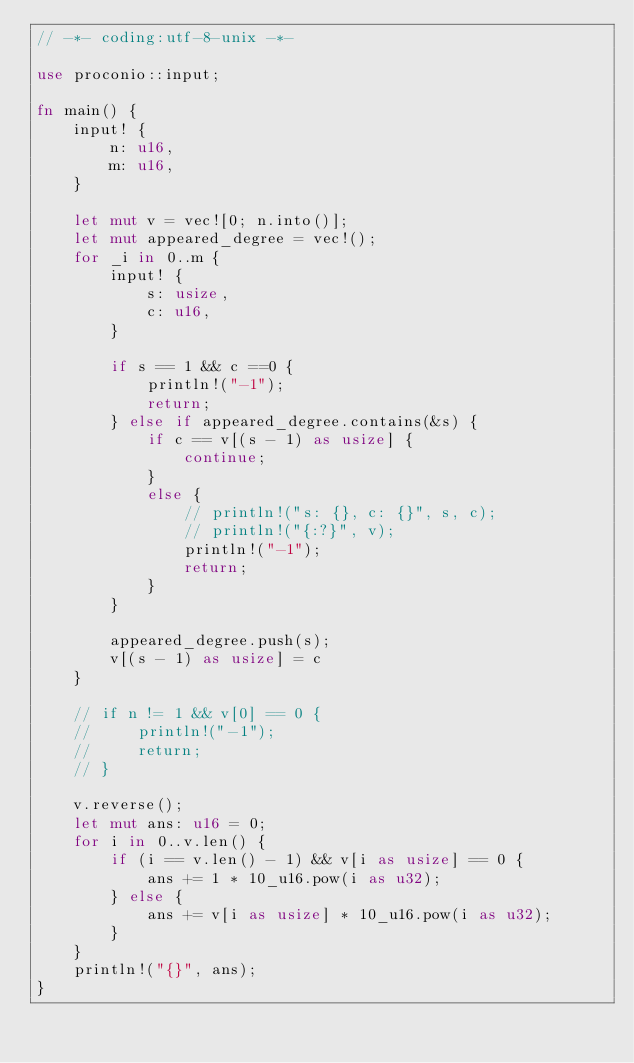Convert code to text. <code><loc_0><loc_0><loc_500><loc_500><_Rust_>// -*- coding:utf-8-unix -*-

use proconio::input;

fn main() {
    input! {
        n: u16,
        m: u16,
    }

    let mut v = vec![0; n.into()];
    let mut appeared_degree = vec!();
    for _i in 0..m {
        input! {
            s: usize,
            c: u16,
        }

        if s == 1 && c ==0 {
            println!("-1");
            return;
        } else if appeared_degree.contains(&s) {
            if c == v[(s - 1) as usize] {
                continue;
            }
            else {
                // println!("s: {}, c: {}", s, c);
                // println!("{:?}", v);
                println!("-1");
                return;
            }
        }

        appeared_degree.push(s);
        v[(s - 1) as usize] = c
    }

    // if n != 1 && v[0] == 0 {
    //     println!("-1");
    //     return;
    // }

    v.reverse();
    let mut ans: u16 = 0;
    for i in 0..v.len() {
        if (i == v.len() - 1) && v[i as usize] == 0 {
            ans += 1 * 10_u16.pow(i as u32);
        } else {
            ans += v[i as usize] * 10_u16.pow(i as u32);
        }
    }
    println!("{}", ans);
}
</code> 